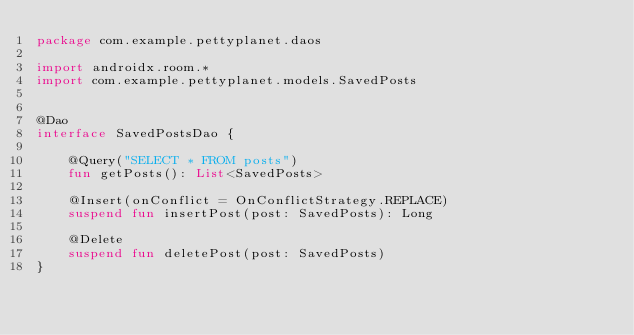<code> <loc_0><loc_0><loc_500><loc_500><_Kotlin_>package com.example.pettyplanet.daos

import androidx.room.*
import com.example.pettyplanet.models.SavedPosts


@Dao
interface SavedPostsDao {

    @Query("SELECT * FROM posts")
    fun getPosts(): List<SavedPosts>

    @Insert(onConflict = OnConflictStrategy.REPLACE)
    suspend fun insertPost(post: SavedPosts): Long

    @Delete
    suspend fun deletePost(post: SavedPosts)
}</code> 